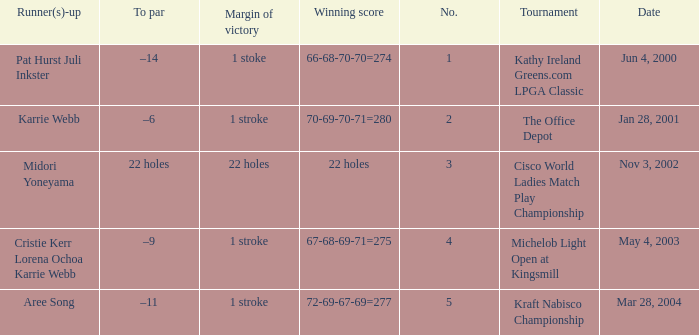Where is the margin of victory dated mar 28, 2004? 1 stroke. Help me parse the entirety of this table. {'header': ['Runner(s)-up', 'To par', 'Margin of victory', 'Winning score', 'No.', 'Tournament', 'Date'], 'rows': [['Pat Hurst Juli Inkster', '–14', '1 stoke', '66-68-70-70=274', '1', 'Kathy Ireland Greens.com LPGA Classic', 'Jun 4, 2000'], ['Karrie Webb', '–6', '1 stroke', '70-69-70-71=280', '2', 'The Office Depot', 'Jan 28, 2001'], ['Midori Yoneyama', '22 holes', '22 holes', '22 holes', '3', 'Cisco World Ladies Match Play Championship', 'Nov 3, 2002'], ['Cristie Kerr Lorena Ochoa Karrie Webb', '–9', '1 stroke', '67-68-69-71=275', '4', 'Michelob Light Open at Kingsmill', 'May 4, 2003'], ['Aree Song', '–11', '1 stroke', '72-69-67-69=277', '5', 'Kraft Nabisco Championship', 'Mar 28, 2004']]} 